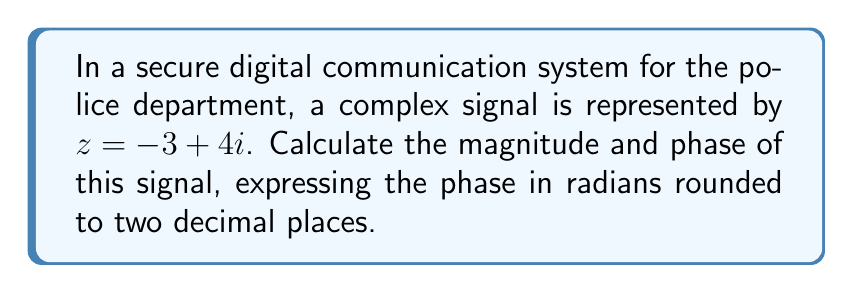Help me with this question. To calculate the magnitude and phase of the complex signal $z = -3 + 4i$, we'll follow these steps:

1. Magnitude calculation:
   The magnitude of a complex number is given by the formula:
   $$|z| = \sqrt{a^2 + b^2}$$
   where $a$ is the real part and $b$ is the imaginary part.

   For $z = -3 + 4i$:
   $$|z| = \sqrt{(-3)^2 + 4^2} = \sqrt{9 + 16} = \sqrt{25} = 5$$

2. Phase calculation:
   The phase (argument) of a complex number is given by the formula:
   $$\theta = \arctan\left(\frac{b}{a}\right)$$
   However, we need to be careful with the quadrant, as arctan alone doesn't give the correct result for all quadrants.

   For $z = -3 + 4i$, we're in the second quadrant (negative real, positive imaginary).
   
   $$\theta = \arctan\left(\frac{4}{-3}\right) + \pi$$
   
   $$\theta = -0.9273 + \pi = 2.2143$$ radians

   Rounding to two decimal places: $2.21$ radians

Therefore, the magnitude is 5, and the phase is 2.21 radians.
Answer: Magnitude: 5, Phase: 2.21 radians 